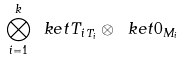<formula> <loc_0><loc_0><loc_500><loc_500>\bigotimes _ { i = 1 } ^ { k } \ k e t { T _ { i } } _ { T _ { i } } \otimes \ k e t { 0 } _ { M _ { i } }</formula> 